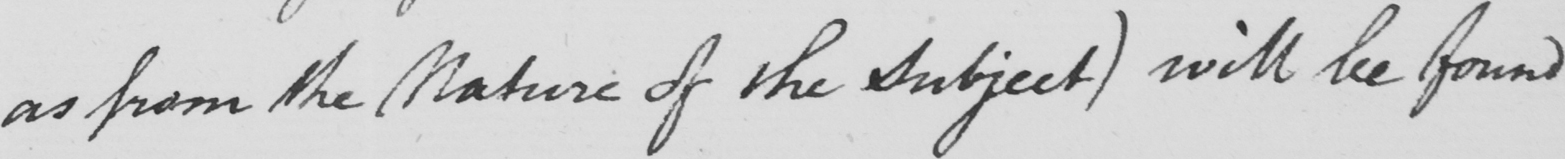What text is written in this handwritten line? as from the Nature of the Subject )  will be found 